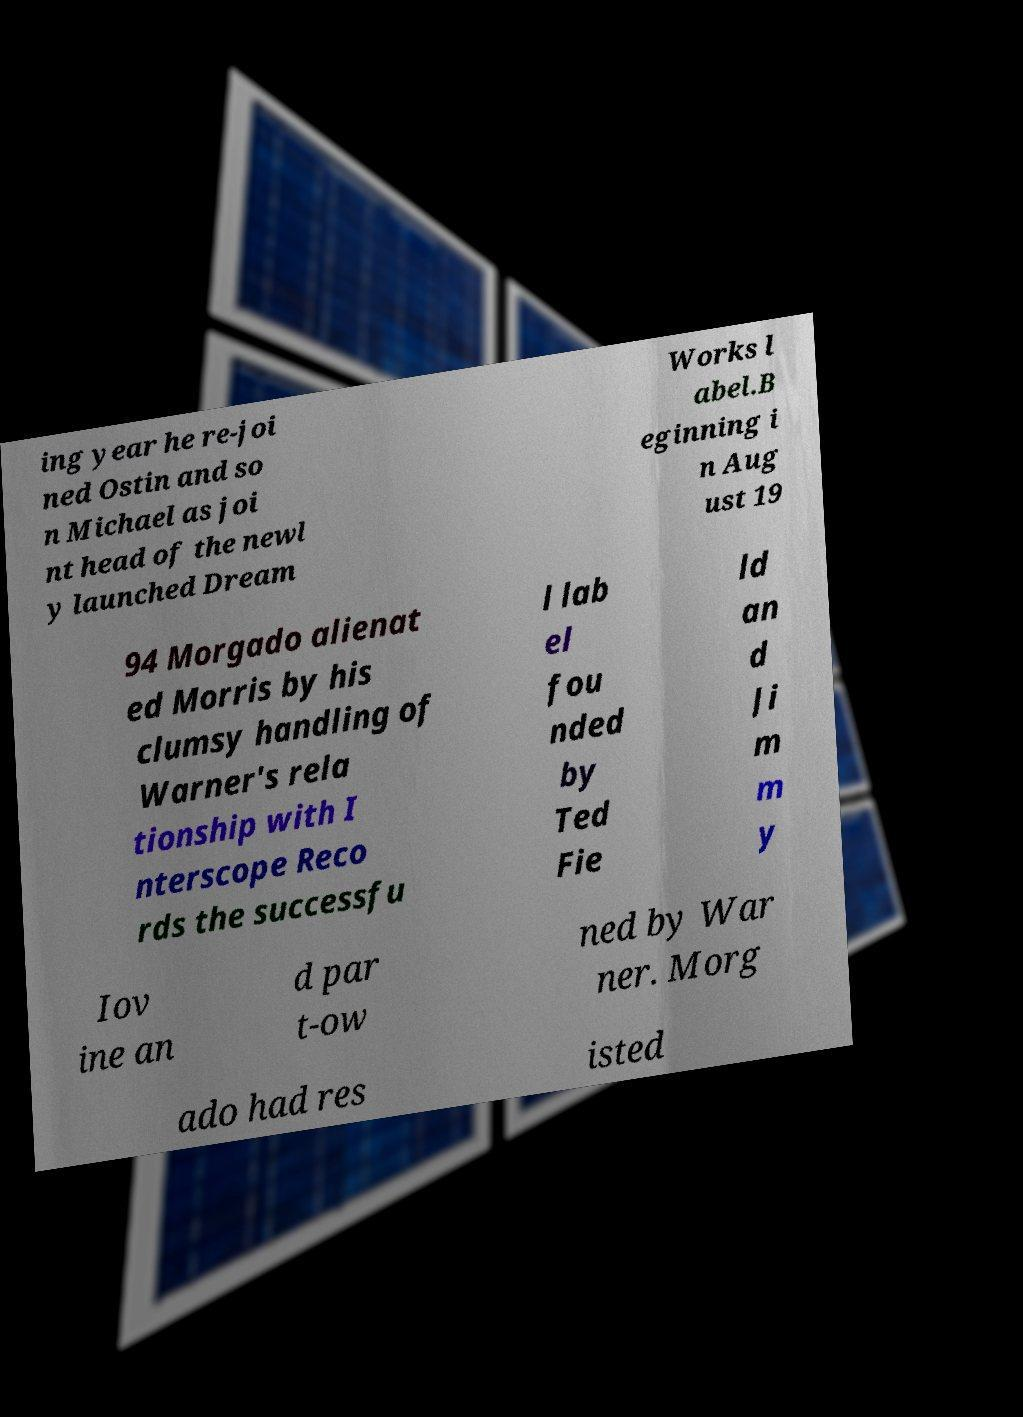For documentation purposes, I need the text within this image transcribed. Could you provide that? ing year he re-joi ned Ostin and so n Michael as joi nt head of the newl y launched Dream Works l abel.B eginning i n Aug ust 19 94 Morgado alienat ed Morris by his clumsy handling of Warner's rela tionship with I nterscope Reco rds the successfu l lab el fou nded by Ted Fie ld an d Ji m m y Iov ine an d par t-ow ned by War ner. Morg ado had res isted 